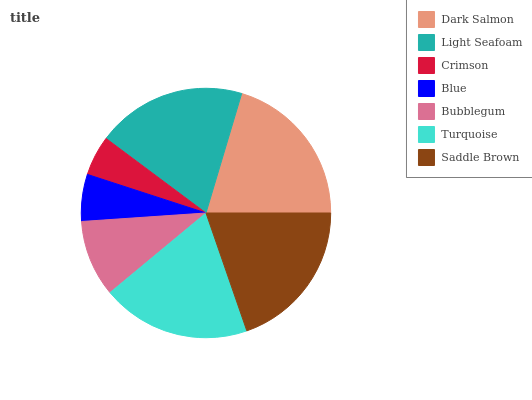Is Crimson the minimum?
Answer yes or no. Yes. Is Dark Salmon the maximum?
Answer yes or no. Yes. Is Light Seafoam the minimum?
Answer yes or no. No. Is Light Seafoam the maximum?
Answer yes or no. No. Is Dark Salmon greater than Light Seafoam?
Answer yes or no. Yes. Is Light Seafoam less than Dark Salmon?
Answer yes or no. Yes. Is Light Seafoam greater than Dark Salmon?
Answer yes or no. No. Is Dark Salmon less than Light Seafoam?
Answer yes or no. No. Is Turquoise the high median?
Answer yes or no. Yes. Is Turquoise the low median?
Answer yes or no. Yes. Is Saddle Brown the high median?
Answer yes or no. No. Is Saddle Brown the low median?
Answer yes or no. No. 